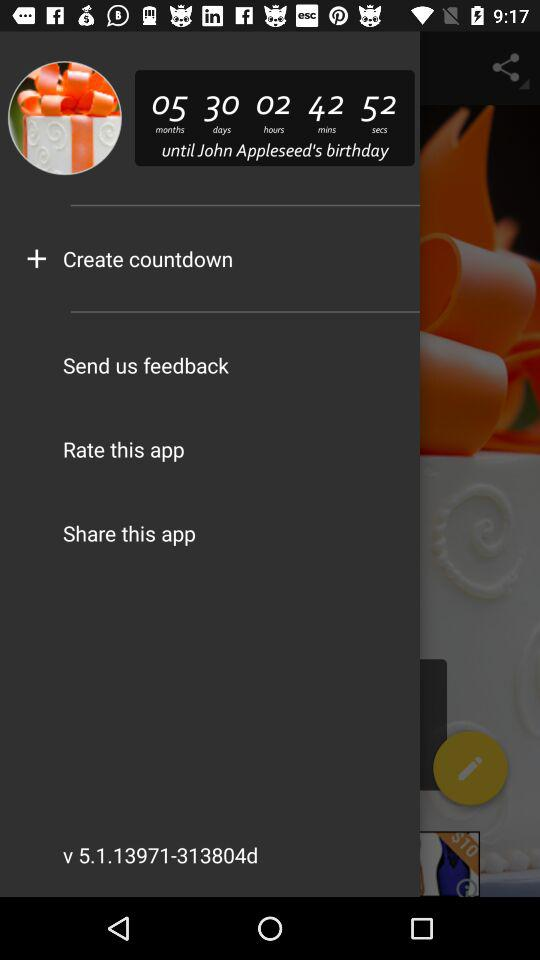What is the user name? The user name is John Appleseed. 